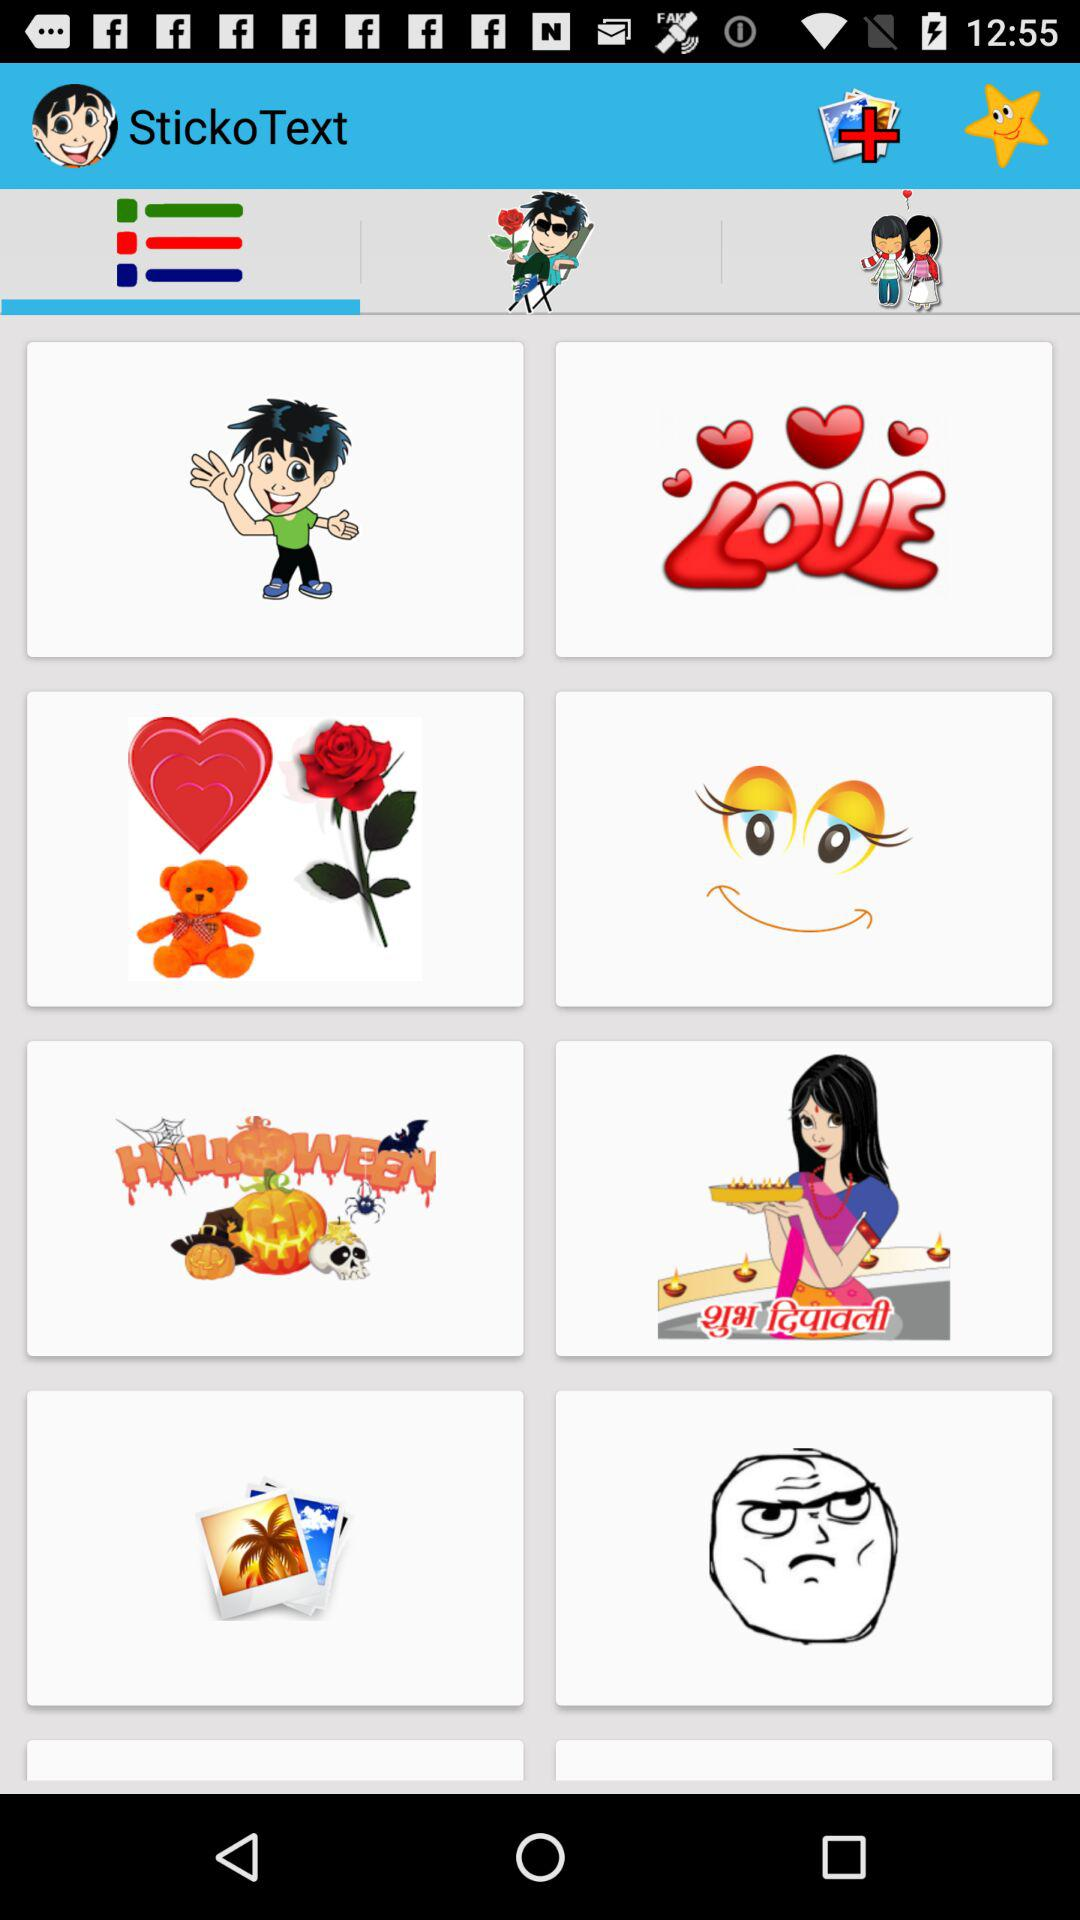Are the stickers free or paid?
When the provided information is insufficient, respond with <no answer>. <no answer> 